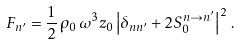Convert formula to latex. <formula><loc_0><loc_0><loc_500><loc_500>F _ { n ^ { \prime } } = \frac { 1 } { 2 } \, \rho _ { 0 } \, \omega ^ { 3 } z _ { 0 } \left | \delta _ { n n ^ { \prime } } + 2 S _ { 0 } ^ { n \to n ^ { \prime } } \right | ^ { 2 } \, .</formula> 